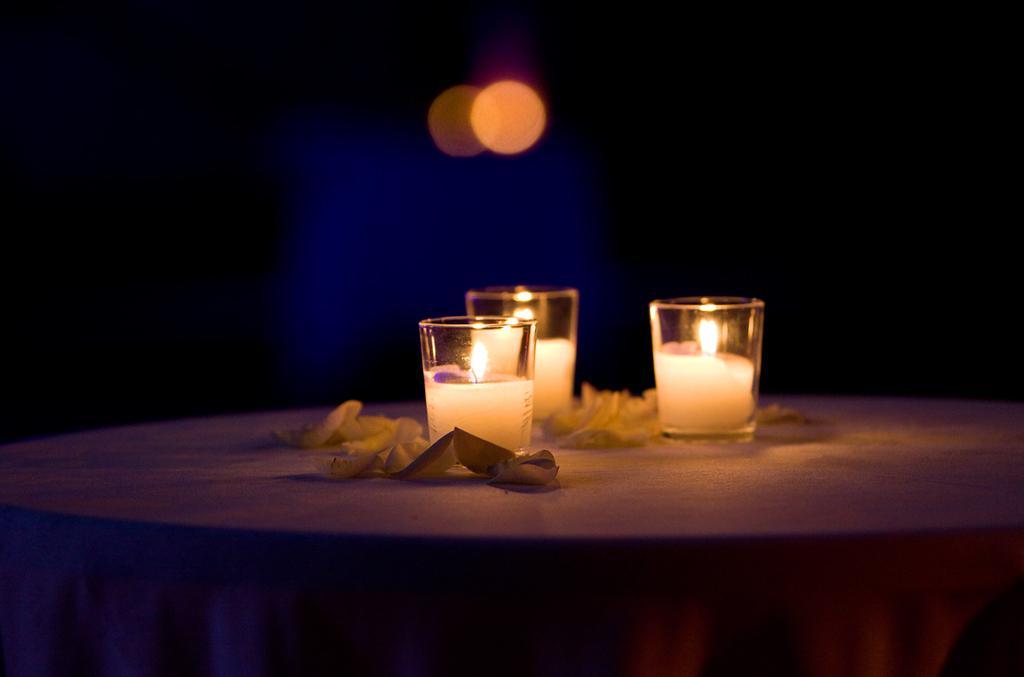Describe this image in one or two sentences. In this picture we can see table and on table we have three glasses with drink in it, cloth. 